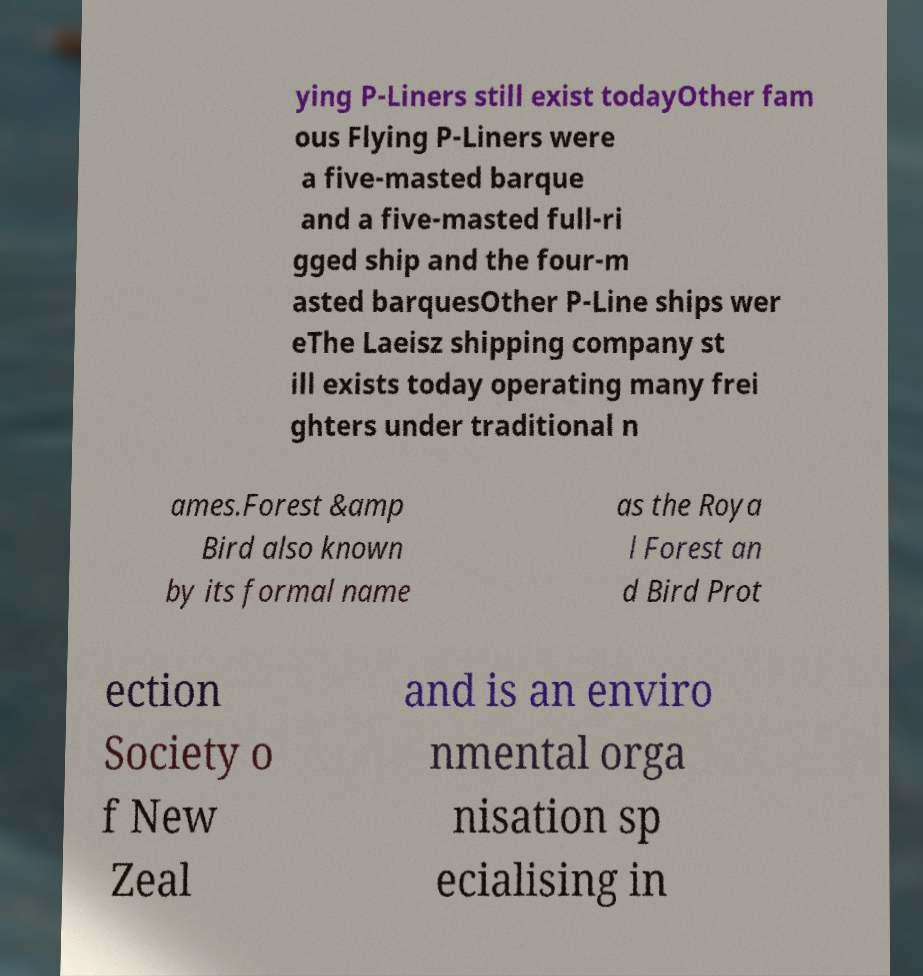Can you accurately transcribe the text from the provided image for me? ying P-Liners still exist todayOther fam ous Flying P-Liners were a five-masted barque and a five-masted full-ri gged ship and the four-m asted barquesOther P-Line ships wer eThe Laeisz shipping company st ill exists today operating many frei ghters under traditional n ames.Forest &amp Bird also known by its formal name as the Roya l Forest an d Bird Prot ection Society o f New Zeal and is an enviro nmental orga nisation sp ecialising in 